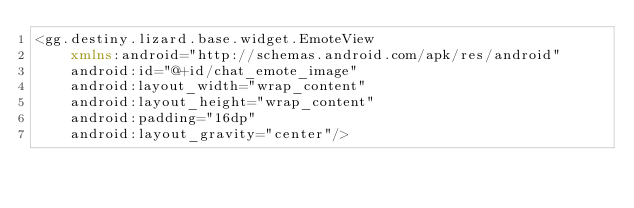Convert code to text. <code><loc_0><loc_0><loc_500><loc_500><_XML_><gg.destiny.lizard.base.widget.EmoteView
    xmlns:android="http://schemas.android.com/apk/res/android"
    android:id="@+id/chat_emote_image"
    android:layout_width="wrap_content"
    android:layout_height="wrap_content"
    android:padding="16dp"
    android:layout_gravity="center"/>
</code> 